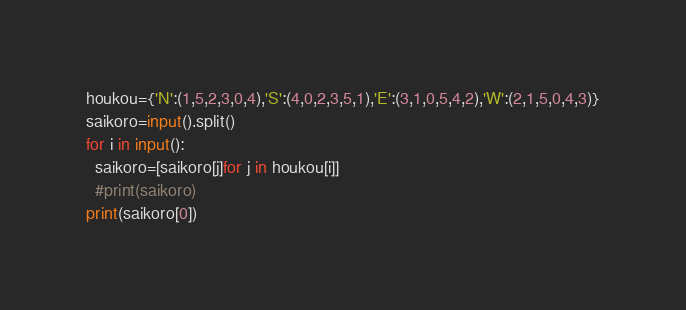<code> <loc_0><loc_0><loc_500><loc_500><_Python_>houkou={'N':(1,5,2,3,0,4),'S':(4,0,2,3,5,1),'E':(3,1,0,5,4,2),'W':(2,1,5,0,4,3)}
saikoro=input().split()
for i in input():
  saikoro=[saikoro[j]for j in houkou[i]]
  #print(saikoro)
print(saikoro[0])
</code> 